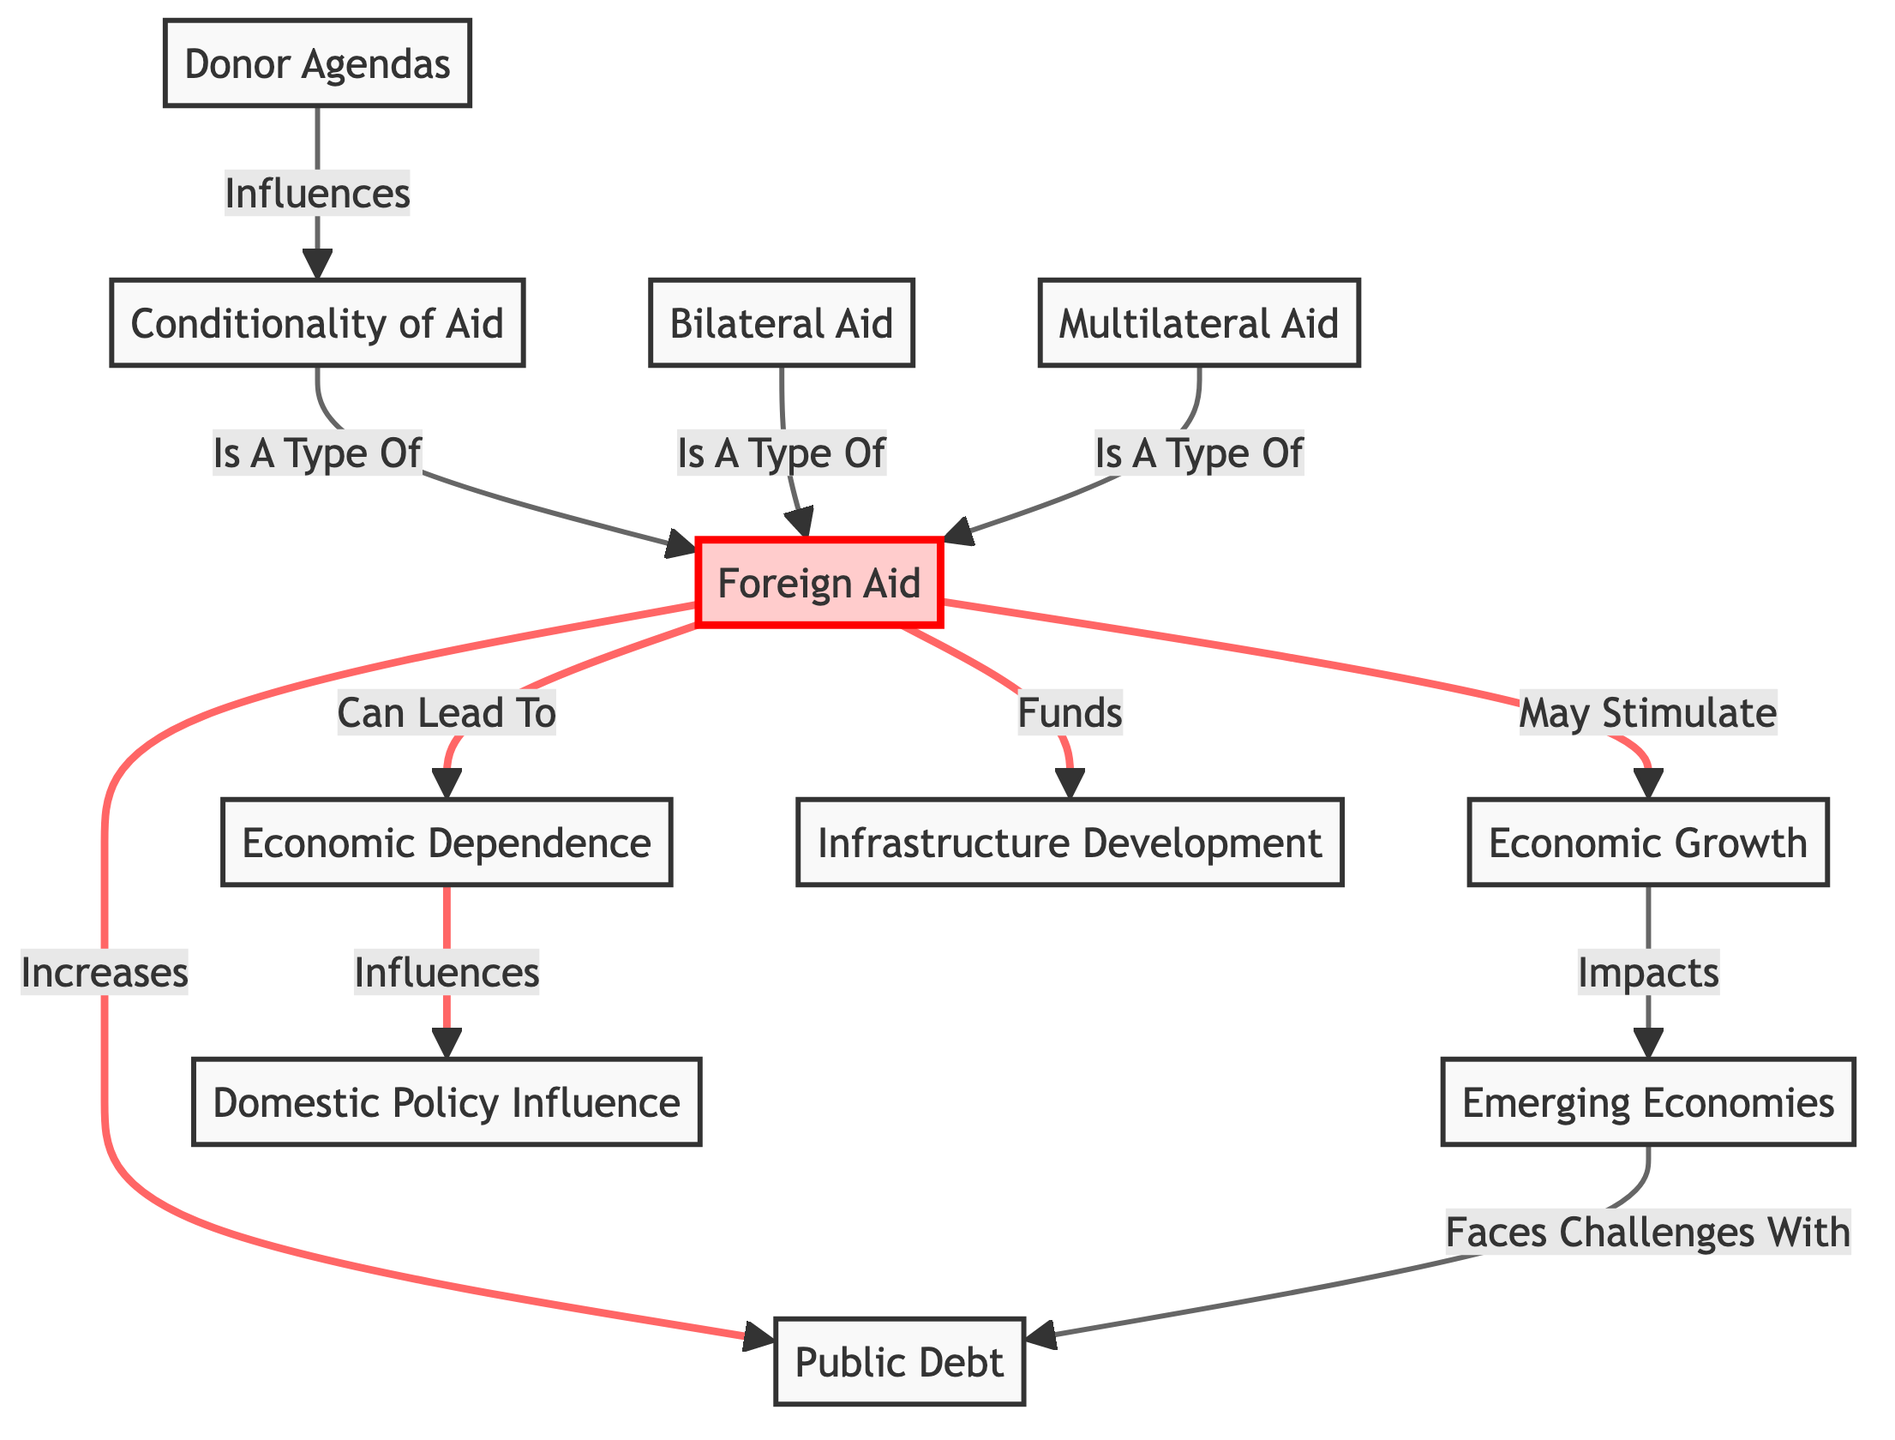What is the relationship between Foreign Aid and Economic Dependence? The diagram indicates that Foreign Aid can lead to Economic Dependence, showing a direct influence where receiving aid affects the economy's independence.
Answer: Can Lead To How many types of foreign aid are represented in the diagram? There are three types of foreign aid mentioned: Conditionality of Aid, Bilateral Aid, and Multilateral Aid, which are all linked to the Foreign Aid node.
Answer: Three What does Public Debt face challenges with? The diagram states that Emerging Economies face challenges with Public Debt, indicating a direct relationship where economic factors affect debt issues in these economies.
Answer: Faces Challenges With What type of aid is influenced by Donor Agendas? The diagram shows that Donor Agendas influence Conditionality of Aid, indicating that the stipulations tied to aid funding are shaped by these agendas.
Answer: Influences What is the impact of Economic Growth on Emerging Economies? According to the diagram, Economic Growth impacts Emerging Economies positively, suggesting that growth has a beneficial effect on the economic status of these countries.
Answer: Impacts Does Foreign Aid fund Infrastructure Development? Yes, the diagram explicitly states that Foreign Aid funds Infrastructure Development, showcasing direct support for building and improving infrastructure through aid.
Answer: Funds What influence does Economic Dependence have? Economic Dependence influences Domestic Policy, indicating that the reliance on external aid can shape the policy decisions made within a country.
Answer: Influences How does Foreign Aid affect Public Debt? The diagram states that Foreign Aid increases Public Debt, highlighting a causal link where dependency on aid may lead to higher levels of debt.
Answer: Increases 